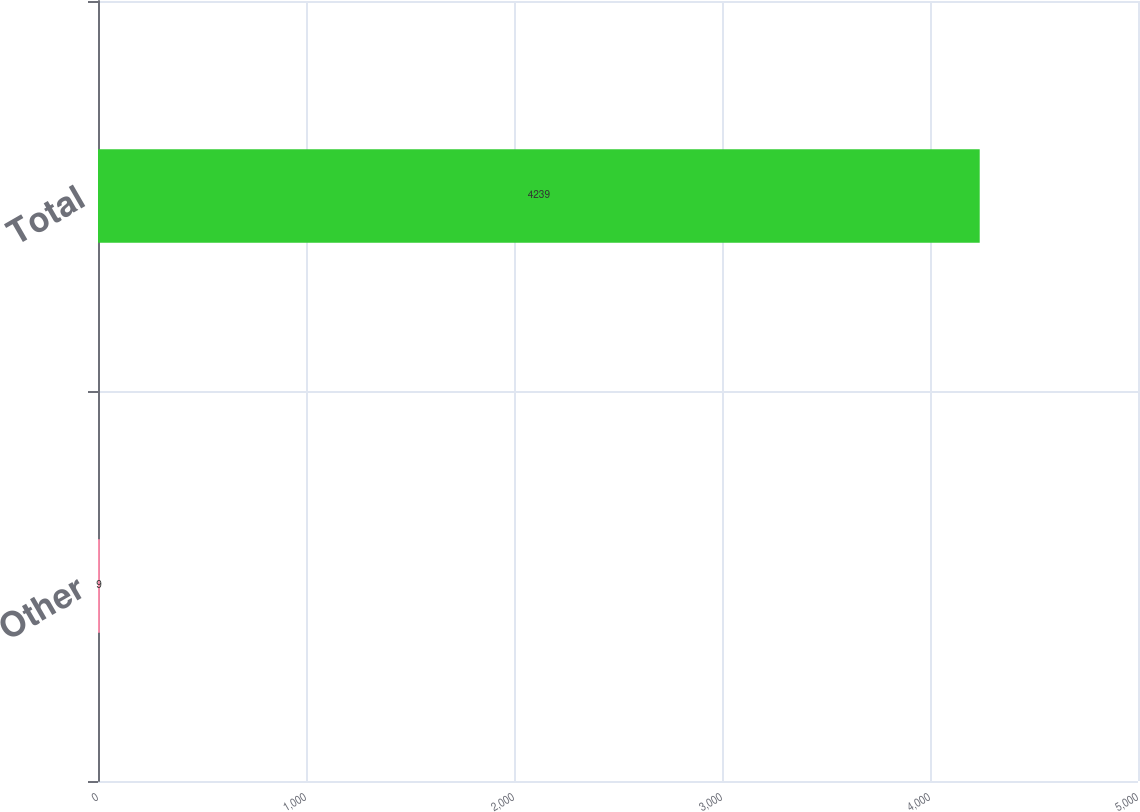<chart> <loc_0><loc_0><loc_500><loc_500><bar_chart><fcel>Other<fcel>Total<nl><fcel>9<fcel>4239<nl></chart> 